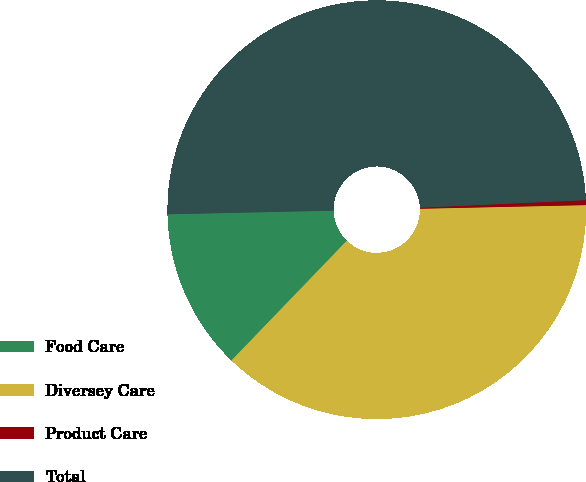<chart> <loc_0><loc_0><loc_500><loc_500><pie_chart><fcel>Food Care<fcel>Diversey Care<fcel>Product Care<fcel>Total<nl><fcel>12.45%<fcel>37.55%<fcel>0.38%<fcel>49.62%<nl></chart> 